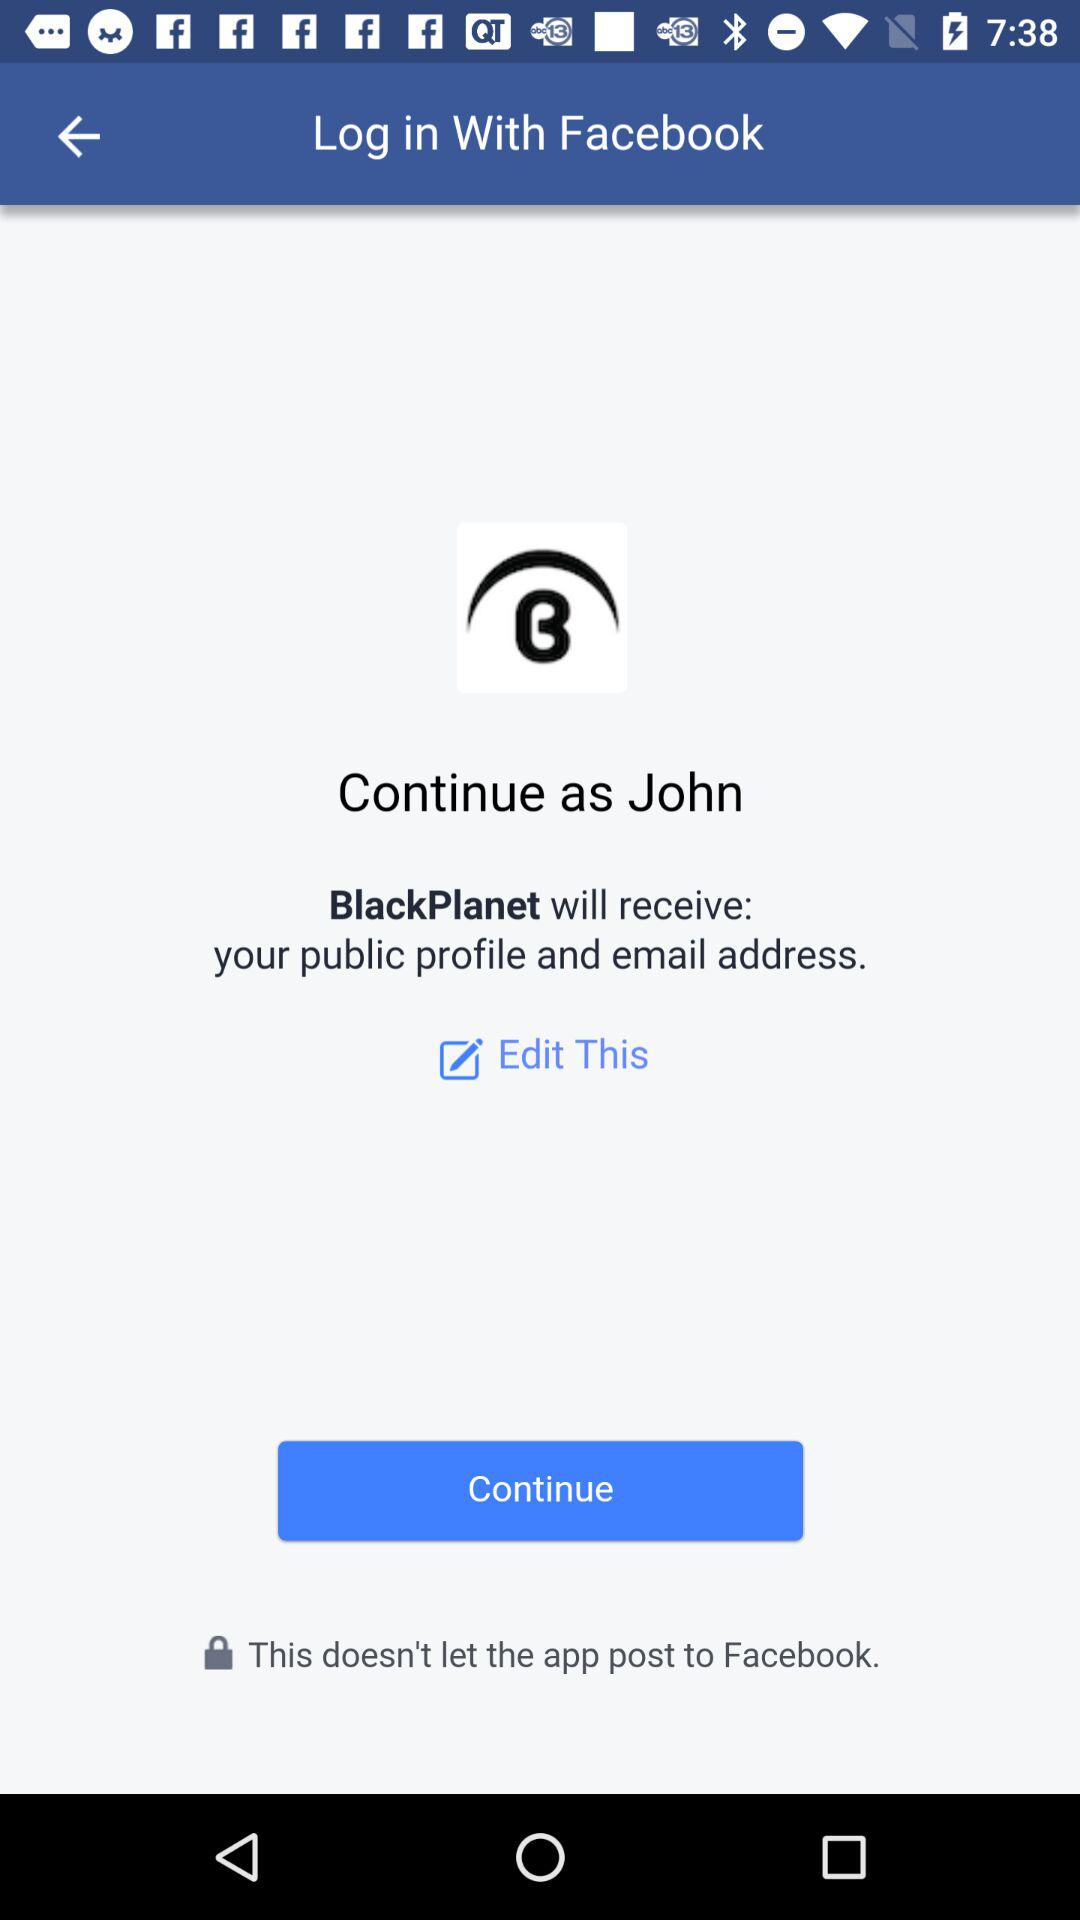What is the login name? The login name is "John". 